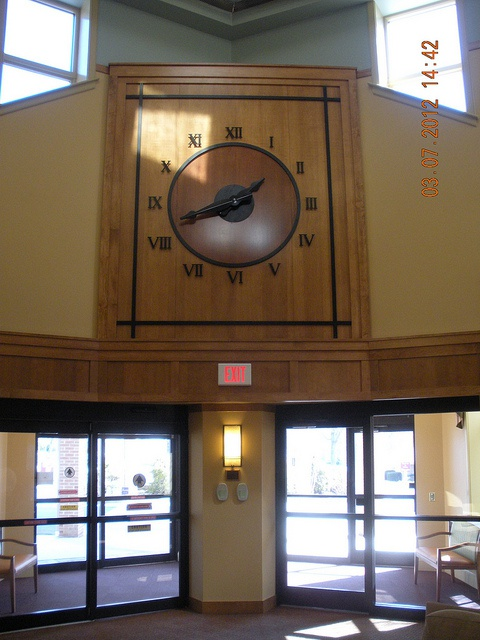Describe the objects in this image and their specific colors. I can see clock in gray, maroon, and black tones, chair in gray and black tones, and chair in gray, black, and darkgray tones in this image. 